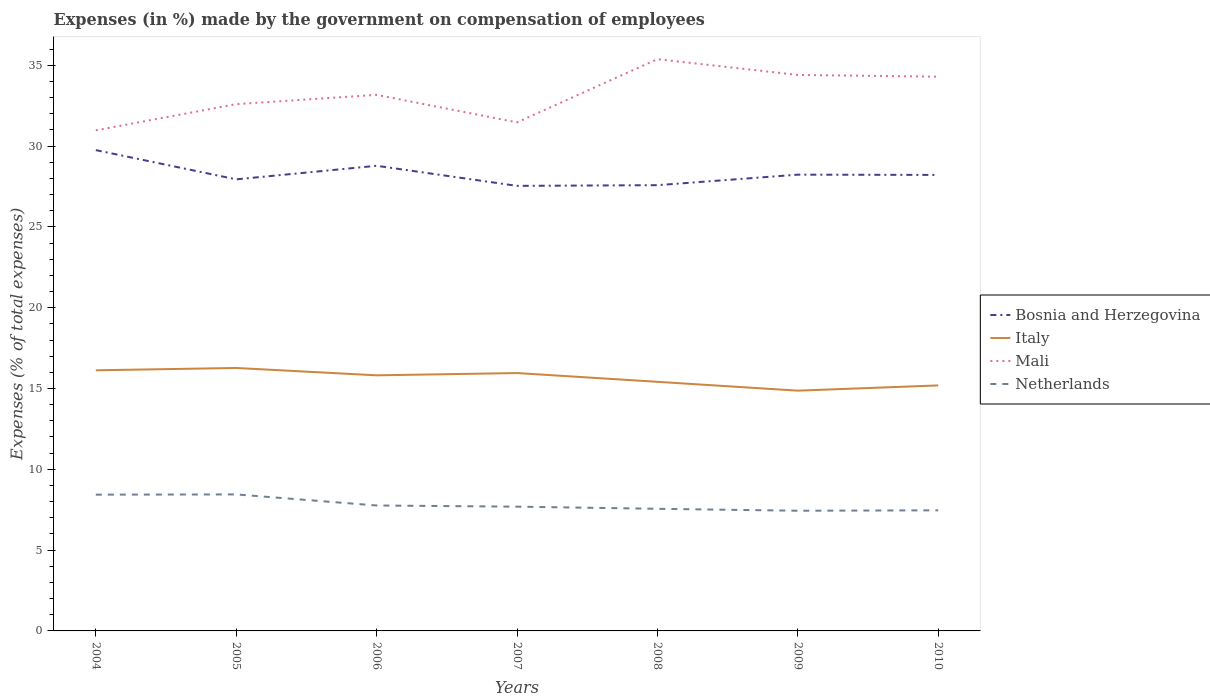Is the number of lines equal to the number of legend labels?
Ensure brevity in your answer.  Yes. Across all years, what is the maximum percentage of expenses made by the government on compensation of employees in Netherlands?
Your response must be concise. 7.44. What is the total percentage of expenses made by the government on compensation of employees in Italy in the graph?
Your response must be concise. 0.31. What is the difference between the highest and the second highest percentage of expenses made by the government on compensation of employees in Bosnia and Herzegovina?
Provide a succinct answer. 2.21. What is the difference between the highest and the lowest percentage of expenses made by the government on compensation of employees in Netherlands?
Provide a short and direct response. 2. How many lines are there?
Provide a succinct answer. 4. How many years are there in the graph?
Offer a terse response. 7. What is the difference between two consecutive major ticks on the Y-axis?
Make the answer very short. 5. Are the values on the major ticks of Y-axis written in scientific E-notation?
Give a very brief answer. No. What is the title of the graph?
Make the answer very short. Expenses (in %) made by the government on compensation of employees. What is the label or title of the Y-axis?
Keep it short and to the point. Expenses (% of total expenses). What is the Expenses (% of total expenses) in Bosnia and Herzegovina in 2004?
Provide a succinct answer. 29.75. What is the Expenses (% of total expenses) of Italy in 2004?
Give a very brief answer. 16.13. What is the Expenses (% of total expenses) of Mali in 2004?
Offer a terse response. 30.98. What is the Expenses (% of total expenses) in Netherlands in 2004?
Ensure brevity in your answer.  8.43. What is the Expenses (% of total expenses) of Bosnia and Herzegovina in 2005?
Ensure brevity in your answer.  27.94. What is the Expenses (% of total expenses) in Italy in 2005?
Your response must be concise. 16.27. What is the Expenses (% of total expenses) in Mali in 2005?
Make the answer very short. 32.6. What is the Expenses (% of total expenses) in Netherlands in 2005?
Make the answer very short. 8.45. What is the Expenses (% of total expenses) in Bosnia and Herzegovina in 2006?
Keep it short and to the point. 28.78. What is the Expenses (% of total expenses) in Italy in 2006?
Give a very brief answer. 15.82. What is the Expenses (% of total expenses) of Mali in 2006?
Your response must be concise. 33.17. What is the Expenses (% of total expenses) in Netherlands in 2006?
Make the answer very short. 7.76. What is the Expenses (% of total expenses) of Bosnia and Herzegovina in 2007?
Your answer should be compact. 27.54. What is the Expenses (% of total expenses) of Italy in 2007?
Your answer should be very brief. 15.96. What is the Expenses (% of total expenses) of Mali in 2007?
Provide a short and direct response. 31.47. What is the Expenses (% of total expenses) of Netherlands in 2007?
Provide a short and direct response. 7.69. What is the Expenses (% of total expenses) of Bosnia and Herzegovina in 2008?
Keep it short and to the point. 27.58. What is the Expenses (% of total expenses) of Italy in 2008?
Make the answer very short. 15.42. What is the Expenses (% of total expenses) of Mali in 2008?
Make the answer very short. 35.38. What is the Expenses (% of total expenses) of Netherlands in 2008?
Your answer should be compact. 7.56. What is the Expenses (% of total expenses) in Bosnia and Herzegovina in 2009?
Your answer should be compact. 28.23. What is the Expenses (% of total expenses) in Italy in 2009?
Make the answer very short. 14.87. What is the Expenses (% of total expenses) in Mali in 2009?
Your answer should be very brief. 34.4. What is the Expenses (% of total expenses) in Netherlands in 2009?
Offer a terse response. 7.44. What is the Expenses (% of total expenses) in Bosnia and Herzegovina in 2010?
Offer a very short reply. 28.22. What is the Expenses (% of total expenses) of Italy in 2010?
Offer a terse response. 15.19. What is the Expenses (% of total expenses) of Mali in 2010?
Give a very brief answer. 34.3. What is the Expenses (% of total expenses) in Netherlands in 2010?
Your answer should be compact. 7.46. Across all years, what is the maximum Expenses (% of total expenses) in Bosnia and Herzegovina?
Provide a short and direct response. 29.75. Across all years, what is the maximum Expenses (% of total expenses) of Italy?
Make the answer very short. 16.27. Across all years, what is the maximum Expenses (% of total expenses) in Mali?
Offer a very short reply. 35.38. Across all years, what is the maximum Expenses (% of total expenses) of Netherlands?
Provide a succinct answer. 8.45. Across all years, what is the minimum Expenses (% of total expenses) of Bosnia and Herzegovina?
Keep it short and to the point. 27.54. Across all years, what is the minimum Expenses (% of total expenses) of Italy?
Make the answer very short. 14.87. Across all years, what is the minimum Expenses (% of total expenses) in Mali?
Ensure brevity in your answer.  30.98. Across all years, what is the minimum Expenses (% of total expenses) of Netherlands?
Your answer should be very brief. 7.44. What is the total Expenses (% of total expenses) of Bosnia and Herzegovina in the graph?
Provide a succinct answer. 198.05. What is the total Expenses (% of total expenses) of Italy in the graph?
Offer a very short reply. 109.65. What is the total Expenses (% of total expenses) in Mali in the graph?
Give a very brief answer. 232.3. What is the total Expenses (% of total expenses) of Netherlands in the graph?
Your answer should be compact. 54.79. What is the difference between the Expenses (% of total expenses) of Bosnia and Herzegovina in 2004 and that in 2005?
Provide a succinct answer. 1.81. What is the difference between the Expenses (% of total expenses) in Italy in 2004 and that in 2005?
Keep it short and to the point. -0.14. What is the difference between the Expenses (% of total expenses) of Mali in 2004 and that in 2005?
Offer a very short reply. -1.62. What is the difference between the Expenses (% of total expenses) of Netherlands in 2004 and that in 2005?
Your response must be concise. -0.01. What is the difference between the Expenses (% of total expenses) of Bosnia and Herzegovina in 2004 and that in 2006?
Give a very brief answer. 0.97. What is the difference between the Expenses (% of total expenses) in Italy in 2004 and that in 2006?
Give a very brief answer. 0.31. What is the difference between the Expenses (% of total expenses) of Mali in 2004 and that in 2006?
Offer a very short reply. -2.2. What is the difference between the Expenses (% of total expenses) of Netherlands in 2004 and that in 2006?
Make the answer very short. 0.67. What is the difference between the Expenses (% of total expenses) of Bosnia and Herzegovina in 2004 and that in 2007?
Give a very brief answer. 2.21. What is the difference between the Expenses (% of total expenses) of Italy in 2004 and that in 2007?
Keep it short and to the point. 0.17. What is the difference between the Expenses (% of total expenses) in Mali in 2004 and that in 2007?
Keep it short and to the point. -0.49. What is the difference between the Expenses (% of total expenses) of Netherlands in 2004 and that in 2007?
Offer a terse response. 0.74. What is the difference between the Expenses (% of total expenses) of Bosnia and Herzegovina in 2004 and that in 2008?
Your response must be concise. 2.17. What is the difference between the Expenses (% of total expenses) in Italy in 2004 and that in 2008?
Ensure brevity in your answer.  0.71. What is the difference between the Expenses (% of total expenses) in Mali in 2004 and that in 2008?
Your answer should be compact. -4.4. What is the difference between the Expenses (% of total expenses) in Netherlands in 2004 and that in 2008?
Provide a short and direct response. 0.88. What is the difference between the Expenses (% of total expenses) of Bosnia and Herzegovina in 2004 and that in 2009?
Offer a very short reply. 1.52. What is the difference between the Expenses (% of total expenses) of Italy in 2004 and that in 2009?
Ensure brevity in your answer.  1.26. What is the difference between the Expenses (% of total expenses) of Mali in 2004 and that in 2009?
Your answer should be very brief. -3.43. What is the difference between the Expenses (% of total expenses) in Bosnia and Herzegovina in 2004 and that in 2010?
Provide a succinct answer. 1.53. What is the difference between the Expenses (% of total expenses) of Italy in 2004 and that in 2010?
Your answer should be compact. 0.94. What is the difference between the Expenses (% of total expenses) of Mali in 2004 and that in 2010?
Your answer should be compact. -3.32. What is the difference between the Expenses (% of total expenses) of Netherlands in 2004 and that in 2010?
Offer a terse response. 0.97. What is the difference between the Expenses (% of total expenses) of Bosnia and Herzegovina in 2005 and that in 2006?
Your answer should be compact. -0.84. What is the difference between the Expenses (% of total expenses) of Italy in 2005 and that in 2006?
Offer a terse response. 0.45. What is the difference between the Expenses (% of total expenses) of Mali in 2005 and that in 2006?
Your answer should be very brief. -0.58. What is the difference between the Expenses (% of total expenses) in Netherlands in 2005 and that in 2006?
Make the answer very short. 0.69. What is the difference between the Expenses (% of total expenses) of Bosnia and Herzegovina in 2005 and that in 2007?
Provide a succinct answer. 0.4. What is the difference between the Expenses (% of total expenses) in Italy in 2005 and that in 2007?
Your answer should be compact. 0.31. What is the difference between the Expenses (% of total expenses) of Mali in 2005 and that in 2007?
Provide a short and direct response. 1.13. What is the difference between the Expenses (% of total expenses) in Netherlands in 2005 and that in 2007?
Offer a terse response. 0.76. What is the difference between the Expenses (% of total expenses) of Bosnia and Herzegovina in 2005 and that in 2008?
Provide a short and direct response. 0.36. What is the difference between the Expenses (% of total expenses) of Italy in 2005 and that in 2008?
Provide a succinct answer. 0.86. What is the difference between the Expenses (% of total expenses) in Mali in 2005 and that in 2008?
Provide a succinct answer. -2.78. What is the difference between the Expenses (% of total expenses) of Netherlands in 2005 and that in 2008?
Your answer should be compact. 0.89. What is the difference between the Expenses (% of total expenses) in Bosnia and Herzegovina in 2005 and that in 2009?
Keep it short and to the point. -0.29. What is the difference between the Expenses (% of total expenses) in Italy in 2005 and that in 2009?
Provide a short and direct response. 1.4. What is the difference between the Expenses (% of total expenses) of Mali in 2005 and that in 2009?
Make the answer very short. -1.81. What is the difference between the Expenses (% of total expenses) of Netherlands in 2005 and that in 2009?
Your answer should be very brief. 1.01. What is the difference between the Expenses (% of total expenses) in Bosnia and Herzegovina in 2005 and that in 2010?
Make the answer very short. -0.27. What is the difference between the Expenses (% of total expenses) in Italy in 2005 and that in 2010?
Make the answer very short. 1.08. What is the difference between the Expenses (% of total expenses) of Mali in 2005 and that in 2010?
Offer a terse response. -1.7. What is the difference between the Expenses (% of total expenses) in Bosnia and Herzegovina in 2006 and that in 2007?
Offer a very short reply. 1.24. What is the difference between the Expenses (% of total expenses) in Italy in 2006 and that in 2007?
Your answer should be very brief. -0.14. What is the difference between the Expenses (% of total expenses) of Mali in 2006 and that in 2007?
Make the answer very short. 1.7. What is the difference between the Expenses (% of total expenses) of Netherlands in 2006 and that in 2007?
Give a very brief answer. 0.07. What is the difference between the Expenses (% of total expenses) in Bosnia and Herzegovina in 2006 and that in 2008?
Offer a terse response. 1.2. What is the difference between the Expenses (% of total expenses) of Italy in 2006 and that in 2008?
Provide a short and direct response. 0.4. What is the difference between the Expenses (% of total expenses) in Mali in 2006 and that in 2008?
Ensure brevity in your answer.  -2.21. What is the difference between the Expenses (% of total expenses) of Netherlands in 2006 and that in 2008?
Ensure brevity in your answer.  0.2. What is the difference between the Expenses (% of total expenses) of Bosnia and Herzegovina in 2006 and that in 2009?
Offer a terse response. 0.55. What is the difference between the Expenses (% of total expenses) in Italy in 2006 and that in 2009?
Provide a succinct answer. 0.95. What is the difference between the Expenses (% of total expenses) of Mali in 2006 and that in 2009?
Make the answer very short. -1.23. What is the difference between the Expenses (% of total expenses) in Netherlands in 2006 and that in 2009?
Your answer should be compact. 0.32. What is the difference between the Expenses (% of total expenses) of Bosnia and Herzegovina in 2006 and that in 2010?
Your answer should be very brief. 0.57. What is the difference between the Expenses (% of total expenses) in Italy in 2006 and that in 2010?
Keep it short and to the point. 0.62. What is the difference between the Expenses (% of total expenses) of Mali in 2006 and that in 2010?
Provide a succinct answer. -1.12. What is the difference between the Expenses (% of total expenses) in Netherlands in 2006 and that in 2010?
Provide a succinct answer. 0.3. What is the difference between the Expenses (% of total expenses) of Bosnia and Herzegovina in 2007 and that in 2008?
Your answer should be compact. -0.04. What is the difference between the Expenses (% of total expenses) of Italy in 2007 and that in 2008?
Ensure brevity in your answer.  0.54. What is the difference between the Expenses (% of total expenses) of Mali in 2007 and that in 2008?
Provide a short and direct response. -3.91. What is the difference between the Expenses (% of total expenses) of Netherlands in 2007 and that in 2008?
Ensure brevity in your answer.  0.13. What is the difference between the Expenses (% of total expenses) of Bosnia and Herzegovina in 2007 and that in 2009?
Your answer should be compact. -0.69. What is the difference between the Expenses (% of total expenses) in Italy in 2007 and that in 2009?
Make the answer very short. 1.09. What is the difference between the Expenses (% of total expenses) of Mali in 2007 and that in 2009?
Your answer should be compact. -2.94. What is the difference between the Expenses (% of total expenses) of Netherlands in 2007 and that in 2009?
Keep it short and to the point. 0.25. What is the difference between the Expenses (% of total expenses) in Bosnia and Herzegovina in 2007 and that in 2010?
Offer a terse response. -0.68. What is the difference between the Expenses (% of total expenses) in Italy in 2007 and that in 2010?
Offer a very short reply. 0.77. What is the difference between the Expenses (% of total expenses) in Mali in 2007 and that in 2010?
Keep it short and to the point. -2.83. What is the difference between the Expenses (% of total expenses) in Netherlands in 2007 and that in 2010?
Provide a short and direct response. 0.23. What is the difference between the Expenses (% of total expenses) of Bosnia and Herzegovina in 2008 and that in 2009?
Give a very brief answer. -0.65. What is the difference between the Expenses (% of total expenses) in Italy in 2008 and that in 2009?
Offer a terse response. 0.55. What is the difference between the Expenses (% of total expenses) in Mali in 2008 and that in 2009?
Offer a terse response. 0.98. What is the difference between the Expenses (% of total expenses) in Netherlands in 2008 and that in 2009?
Provide a short and direct response. 0.12. What is the difference between the Expenses (% of total expenses) of Bosnia and Herzegovina in 2008 and that in 2010?
Make the answer very short. -0.63. What is the difference between the Expenses (% of total expenses) in Italy in 2008 and that in 2010?
Your answer should be compact. 0.22. What is the difference between the Expenses (% of total expenses) in Mali in 2008 and that in 2010?
Offer a terse response. 1.08. What is the difference between the Expenses (% of total expenses) in Netherlands in 2008 and that in 2010?
Ensure brevity in your answer.  0.1. What is the difference between the Expenses (% of total expenses) in Bosnia and Herzegovina in 2009 and that in 2010?
Make the answer very short. 0.02. What is the difference between the Expenses (% of total expenses) in Italy in 2009 and that in 2010?
Offer a terse response. -0.32. What is the difference between the Expenses (% of total expenses) of Mali in 2009 and that in 2010?
Offer a terse response. 0.11. What is the difference between the Expenses (% of total expenses) of Netherlands in 2009 and that in 2010?
Give a very brief answer. -0.02. What is the difference between the Expenses (% of total expenses) of Bosnia and Herzegovina in 2004 and the Expenses (% of total expenses) of Italy in 2005?
Ensure brevity in your answer.  13.48. What is the difference between the Expenses (% of total expenses) in Bosnia and Herzegovina in 2004 and the Expenses (% of total expenses) in Mali in 2005?
Ensure brevity in your answer.  -2.84. What is the difference between the Expenses (% of total expenses) of Bosnia and Herzegovina in 2004 and the Expenses (% of total expenses) of Netherlands in 2005?
Give a very brief answer. 21.31. What is the difference between the Expenses (% of total expenses) in Italy in 2004 and the Expenses (% of total expenses) in Mali in 2005?
Offer a terse response. -16.47. What is the difference between the Expenses (% of total expenses) in Italy in 2004 and the Expenses (% of total expenses) in Netherlands in 2005?
Ensure brevity in your answer.  7.68. What is the difference between the Expenses (% of total expenses) of Mali in 2004 and the Expenses (% of total expenses) of Netherlands in 2005?
Ensure brevity in your answer.  22.53. What is the difference between the Expenses (% of total expenses) in Bosnia and Herzegovina in 2004 and the Expenses (% of total expenses) in Italy in 2006?
Provide a succinct answer. 13.94. What is the difference between the Expenses (% of total expenses) of Bosnia and Herzegovina in 2004 and the Expenses (% of total expenses) of Mali in 2006?
Your response must be concise. -3.42. What is the difference between the Expenses (% of total expenses) of Bosnia and Herzegovina in 2004 and the Expenses (% of total expenses) of Netherlands in 2006?
Provide a short and direct response. 21.99. What is the difference between the Expenses (% of total expenses) of Italy in 2004 and the Expenses (% of total expenses) of Mali in 2006?
Provide a succinct answer. -17.05. What is the difference between the Expenses (% of total expenses) of Italy in 2004 and the Expenses (% of total expenses) of Netherlands in 2006?
Give a very brief answer. 8.37. What is the difference between the Expenses (% of total expenses) in Mali in 2004 and the Expenses (% of total expenses) in Netherlands in 2006?
Your answer should be very brief. 23.22. What is the difference between the Expenses (% of total expenses) in Bosnia and Herzegovina in 2004 and the Expenses (% of total expenses) in Italy in 2007?
Ensure brevity in your answer.  13.79. What is the difference between the Expenses (% of total expenses) of Bosnia and Herzegovina in 2004 and the Expenses (% of total expenses) of Mali in 2007?
Ensure brevity in your answer.  -1.72. What is the difference between the Expenses (% of total expenses) of Bosnia and Herzegovina in 2004 and the Expenses (% of total expenses) of Netherlands in 2007?
Ensure brevity in your answer.  22.06. What is the difference between the Expenses (% of total expenses) in Italy in 2004 and the Expenses (% of total expenses) in Mali in 2007?
Your answer should be very brief. -15.34. What is the difference between the Expenses (% of total expenses) of Italy in 2004 and the Expenses (% of total expenses) of Netherlands in 2007?
Make the answer very short. 8.44. What is the difference between the Expenses (% of total expenses) of Mali in 2004 and the Expenses (% of total expenses) of Netherlands in 2007?
Ensure brevity in your answer.  23.29. What is the difference between the Expenses (% of total expenses) in Bosnia and Herzegovina in 2004 and the Expenses (% of total expenses) in Italy in 2008?
Offer a terse response. 14.34. What is the difference between the Expenses (% of total expenses) in Bosnia and Herzegovina in 2004 and the Expenses (% of total expenses) in Mali in 2008?
Provide a succinct answer. -5.63. What is the difference between the Expenses (% of total expenses) in Bosnia and Herzegovina in 2004 and the Expenses (% of total expenses) in Netherlands in 2008?
Offer a terse response. 22.19. What is the difference between the Expenses (% of total expenses) of Italy in 2004 and the Expenses (% of total expenses) of Mali in 2008?
Your answer should be very brief. -19.25. What is the difference between the Expenses (% of total expenses) of Italy in 2004 and the Expenses (% of total expenses) of Netherlands in 2008?
Offer a terse response. 8.57. What is the difference between the Expenses (% of total expenses) in Mali in 2004 and the Expenses (% of total expenses) in Netherlands in 2008?
Provide a succinct answer. 23.42. What is the difference between the Expenses (% of total expenses) of Bosnia and Herzegovina in 2004 and the Expenses (% of total expenses) of Italy in 2009?
Ensure brevity in your answer.  14.88. What is the difference between the Expenses (% of total expenses) in Bosnia and Herzegovina in 2004 and the Expenses (% of total expenses) in Mali in 2009?
Offer a very short reply. -4.65. What is the difference between the Expenses (% of total expenses) of Bosnia and Herzegovina in 2004 and the Expenses (% of total expenses) of Netherlands in 2009?
Offer a very short reply. 22.32. What is the difference between the Expenses (% of total expenses) of Italy in 2004 and the Expenses (% of total expenses) of Mali in 2009?
Your answer should be very brief. -18.28. What is the difference between the Expenses (% of total expenses) of Italy in 2004 and the Expenses (% of total expenses) of Netherlands in 2009?
Provide a succinct answer. 8.69. What is the difference between the Expenses (% of total expenses) of Mali in 2004 and the Expenses (% of total expenses) of Netherlands in 2009?
Make the answer very short. 23.54. What is the difference between the Expenses (% of total expenses) of Bosnia and Herzegovina in 2004 and the Expenses (% of total expenses) of Italy in 2010?
Your answer should be compact. 14.56. What is the difference between the Expenses (% of total expenses) in Bosnia and Herzegovina in 2004 and the Expenses (% of total expenses) in Mali in 2010?
Offer a terse response. -4.54. What is the difference between the Expenses (% of total expenses) in Bosnia and Herzegovina in 2004 and the Expenses (% of total expenses) in Netherlands in 2010?
Your answer should be compact. 22.29. What is the difference between the Expenses (% of total expenses) of Italy in 2004 and the Expenses (% of total expenses) of Mali in 2010?
Give a very brief answer. -18.17. What is the difference between the Expenses (% of total expenses) in Italy in 2004 and the Expenses (% of total expenses) in Netherlands in 2010?
Your response must be concise. 8.67. What is the difference between the Expenses (% of total expenses) of Mali in 2004 and the Expenses (% of total expenses) of Netherlands in 2010?
Provide a succinct answer. 23.52. What is the difference between the Expenses (% of total expenses) in Bosnia and Herzegovina in 2005 and the Expenses (% of total expenses) in Italy in 2006?
Your response must be concise. 12.13. What is the difference between the Expenses (% of total expenses) in Bosnia and Herzegovina in 2005 and the Expenses (% of total expenses) in Mali in 2006?
Keep it short and to the point. -5.23. What is the difference between the Expenses (% of total expenses) of Bosnia and Herzegovina in 2005 and the Expenses (% of total expenses) of Netherlands in 2006?
Keep it short and to the point. 20.18. What is the difference between the Expenses (% of total expenses) in Italy in 2005 and the Expenses (% of total expenses) in Mali in 2006?
Keep it short and to the point. -16.9. What is the difference between the Expenses (% of total expenses) of Italy in 2005 and the Expenses (% of total expenses) of Netherlands in 2006?
Provide a short and direct response. 8.51. What is the difference between the Expenses (% of total expenses) in Mali in 2005 and the Expenses (% of total expenses) in Netherlands in 2006?
Keep it short and to the point. 24.84. What is the difference between the Expenses (% of total expenses) of Bosnia and Herzegovina in 2005 and the Expenses (% of total expenses) of Italy in 2007?
Ensure brevity in your answer.  11.99. What is the difference between the Expenses (% of total expenses) of Bosnia and Herzegovina in 2005 and the Expenses (% of total expenses) of Mali in 2007?
Provide a short and direct response. -3.52. What is the difference between the Expenses (% of total expenses) in Bosnia and Herzegovina in 2005 and the Expenses (% of total expenses) in Netherlands in 2007?
Offer a very short reply. 20.25. What is the difference between the Expenses (% of total expenses) of Italy in 2005 and the Expenses (% of total expenses) of Mali in 2007?
Offer a terse response. -15.2. What is the difference between the Expenses (% of total expenses) in Italy in 2005 and the Expenses (% of total expenses) in Netherlands in 2007?
Make the answer very short. 8.58. What is the difference between the Expenses (% of total expenses) in Mali in 2005 and the Expenses (% of total expenses) in Netherlands in 2007?
Make the answer very short. 24.91. What is the difference between the Expenses (% of total expenses) of Bosnia and Herzegovina in 2005 and the Expenses (% of total expenses) of Italy in 2008?
Provide a short and direct response. 12.53. What is the difference between the Expenses (% of total expenses) of Bosnia and Herzegovina in 2005 and the Expenses (% of total expenses) of Mali in 2008?
Give a very brief answer. -7.44. What is the difference between the Expenses (% of total expenses) of Bosnia and Herzegovina in 2005 and the Expenses (% of total expenses) of Netherlands in 2008?
Your response must be concise. 20.39. What is the difference between the Expenses (% of total expenses) in Italy in 2005 and the Expenses (% of total expenses) in Mali in 2008?
Keep it short and to the point. -19.11. What is the difference between the Expenses (% of total expenses) in Italy in 2005 and the Expenses (% of total expenses) in Netherlands in 2008?
Your answer should be very brief. 8.71. What is the difference between the Expenses (% of total expenses) of Mali in 2005 and the Expenses (% of total expenses) of Netherlands in 2008?
Your answer should be compact. 25.04. What is the difference between the Expenses (% of total expenses) of Bosnia and Herzegovina in 2005 and the Expenses (% of total expenses) of Italy in 2009?
Offer a terse response. 13.08. What is the difference between the Expenses (% of total expenses) of Bosnia and Herzegovina in 2005 and the Expenses (% of total expenses) of Mali in 2009?
Keep it short and to the point. -6.46. What is the difference between the Expenses (% of total expenses) of Bosnia and Herzegovina in 2005 and the Expenses (% of total expenses) of Netherlands in 2009?
Make the answer very short. 20.51. What is the difference between the Expenses (% of total expenses) in Italy in 2005 and the Expenses (% of total expenses) in Mali in 2009?
Provide a short and direct response. -18.13. What is the difference between the Expenses (% of total expenses) of Italy in 2005 and the Expenses (% of total expenses) of Netherlands in 2009?
Your answer should be very brief. 8.83. What is the difference between the Expenses (% of total expenses) in Mali in 2005 and the Expenses (% of total expenses) in Netherlands in 2009?
Keep it short and to the point. 25.16. What is the difference between the Expenses (% of total expenses) in Bosnia and Herzegovina in 2005 and the Expenses (% of total expenses) in Italy in 2010?
Keep it short and to the point. 12.75. What is the difference between the Expenses (% of total expenses) of Bosnia and Herzegovina in 2005 and the Expenses (% of total expenses) of Mali in 2010?
Make the answer very short. -6.35. What is the difference between the Expenses (% of total expenses) in Bosnia and Herzegovina in 2005 and the Expenses (% of total expenses) in Netherlands in 2010?
Keep it short and to the point. 20.48. What is the difference between the Expenses (% of total expenses) of Italy in 2005 and the Expenses (% of total expenses) of Mali in 2010?
Your answer should be compact. -18.03. What is the difference between the Expenses (% of total expenses) in Italy in 2005 and the Expenses (% of total expenses) in Netherlands in 2010?
Your answer should be very brief. 8.81. What is the difference between the Expenses (% of total expenses) in Mali in 2005 and the Expenses (% of total expenses) in Netherlands in 2010?
Your response must be concise. 25.13. What is the difference between the Expenses (% of total expenses) of Bosnia and Herzegovina in 2006 and the Expenses (% of total expenses) of Italy in 2007?
Ensure brevity in your answer.  12.83. What is the difference between the Expenses (% of total expenses) in Bosnia and Herzegovina in 2006 and the Expenses (% of total expenses) in Mali in 2007?
Provide a short and direct response. -2.69. What is the difference between the Expenses (% of total expenses) in Bosnia and Herzegovina in 2006 and the Expenses (% of total expenses) in Netherlands in 2007?
Your answer should be compact. 21.09. What is the difference between the Expenses (% of total expenses) in Italy in 2006 and the Expenses (% of total expenses) in Mali in 2007?
Provide a short and direct response. -15.65. What is the difference between the Expenses (% of total expenses) of Italy in 2006 and the Expenses (% of total expenses) of Netherlands in 2007?
Your answer should be very brief. 8.13. What is the difference between the Expenses (% of total expenses) of Mali in 2006 and the Expenses (% of total expenses) of Netherlands in 2007?
Provide a succinct answer. 25.48. What is the difference between the Expenses (% of total expenses) of Bosnia and Herzegovina in 2006 and the Expenses (% of total expenses) of Italy in 2008?
Offer a terse response. 13.37. What is the difference between the Expenses (% of total expenses) of Bosnia and Herzegovina in 2006 and the Expenses (% of total expenses) of Mali in 2008?
Keep it short and to the point. -6.6. What is the difference between the Expenses (% of total expenses) of Bosnia and Herzegovina in 2006 and the Expenses (% of total expenses) of Netherlands in 2008?
Provide a succinct answer. 21.23. What is the difference between the Expenses (% of total expenses) of Italy in 2006 and the Expenses (% of total expenses) of Mali in 2008?
Ensure brevity in your answer.  -19.56. What is the difference between the Expenses (% of total expenses) in Italy in 2006 and the Expenses (% of total expenses) in Netherlands in 2008?
Give a very brief answer. 8.26. What is the difference between the Expenses (% of total expenses) in Mali in 2006 and the Expenses (% of total expenses) in Netherlands in 2008?
Provide a short and direct response. 25.62. What is the difference between the Expenses (% of total expenses) in Bosnia and Herzegovina in 2006 and the Expenses (% of total expenses) in Italy in 2009?
Offer a very short reply. 13.92. What is the difference between the Expenses (% of total expenses) of Bosnia and Herzegovina in 2006 and the Expenses (% of total expenses) of Mali in 2009?
Keep it short and to the point. -5.62. What is the difference between the Expenses (% of total expenses) in Bosnia and Herzegovina in 2006 and the Expenses (% of total expenses) in Netherlands in 2009?
Offer a very short reply. 21.35. What is the difference between the Expenses (% of total expenses) in Italy in 2006 and the Expenses (% of total expenses) in Mali in 2009?
Offer a very short reply. -18.59. What is the difference between the Expenses (% of total expenses) of Italy in 2006 and the Expenses (% of total expenses) of Netherlands in 2009?
Give a very brief answer. 8.38. What is the difference between the Expenses (% of total expenses) in Mali in 2006 and the Expenses (% of total expenses) in Netherlands in 2009?
Your answer should be very brief. 25.74. What is the difference between the Expenses (% of total expenses) in Bosnia and Herzegovina in 2006 and the Expenses (% of total expenses) in Italy in 2010?
Keep it short and to the point. 13.59. What is the difference between the Expenses (% of total expenses) of Bosnia and Herzegovina in 2006 and the Expenses (% of total expenses) of Mali in 2010?
Give a very brief answer. -5.51. What is the difference between the Expenses (% of total expenses) of Bosnia and Herzegovina in 2006 and the Expenses (% of total expenses) of Netherlands in 2010?
Your answer should be very brief. 21.32. What is the difference between the Expenses (% of total expenses) of Italy in 2006 and the Expenses (% of total expenses) of Mali in 2010?
Ensure brevity in your answer.  -18.48. What is the difference between the Expenses (% of total expenses) in Italy in 2006 and the Expenses (% of total expenses) in Netherlands in 2010?
Ensure brevity in your answer.  8.35. What is the difference between the Expenses (% of total expenses) in Mali in 2006 and the Expenses (% of total expenses) in Netherlands in 2010?
Offer a very short reply. 25.71. What is the difference between the Expenses (% of total expenses) in Bosnia and Herzegovina in 2007 and the Expenses (% of total expenses) in Italy in 2008?
Give a very brief answer. 12.12. What is the difference between the Expenses (% of total expenses) of Bosnia and Herzegovina in 2007 and the Expenses (% of total expenses) of Mali in 2008?
Your answer should be compact. -7.84. What is the difference between the Expenses (% of total expenses) in Bosnia and Herzegovina in 2007 and the Expenses (% of total expenses) in Netherlands in 2008?
Your response must be concise. 19.98. What is the difference between the Expenses (% of total expenses) in Italy in 2007 and the Expenses (% of total expenses) in Mali in 2008?
Offer a terse response. -19.42. What is the difference between the Expenses (% of total expenses) of Mali in 2007 and the Expenses (% of total expenses) of Netherlands in 2008?
Your response must be concise. 23.91. What is the difference between the Expenses (% of total expenses) in Bosnia and Herzegovina in 2007 and the Expenses (% of total expenses) in Italy in 2009?
Your answer should be compact. 12.67. What is the difference between the Expenses (% of total expenses) of Bosnia and Herzegovina in 2007 and the Expenses (% of total expenses) of Mali in 2009?
Provide a short and direct response. -6.86. What is the difference between the Expenses (% of total expenses) of Bosnia and Herzegovina in 2007 and the Expenses (% of total expenses) of Netherlands in 2009?
Keep it short and to the point. 20.1. What is the difference between the Expenses (% of total expenses) of Italy in 2007 and the Expenses (% of total expenses) of Mali in 2009?
Ensure brevity in your answer.  -18.45. What is the difference between the Expenses (% of total expenses) in Italy in 2007 and the Expenses (% of total expenses) in Netherlands in 2009?
Provide a short and direct response. 8.52. What is the difference between the Expenses (% of total expenses) in Mali in 2007 and the Expenses (% of total expenses) in Netherlands in 2009?
Ensure brevity in your answer.  24.03. What is the difference between the Expenses (% of total expenses) of Bosnia and Herzegovina in 2007 and the Expenses (% of total expenses) of Italy in 2010?
Your response must be concise. 12.35. What is the difference between the Expenses (% of total expenses) of Bosnia and Herzegovina in 2007 and the Expenses (% of total expenses) of Mali in 2010?
Offer a terse response. -6.76. What is the difference between the Expenses (% of total expenses) in Bosnia and Herzegovina in 2007 and the Expenses (% of total expenses) in Netherlands in 2010?
Ensure brevity in your answer.  20.08. What is the difference between the Expenses (% of total expenses) in Italy in 2007 and the Expenses (% of total expenses) in Mali in 2010?
Offer a terse response. -18.34. What is the difference between the Expenses (% of total expenses) in Italy in 2007 and the Expenses (% of total expenses) in Netherlands in 2010?
Your response must be concise. 8.5. What is the difference between the Expenses (% of total expenses) in Mali in 2007 and the Expenses (% of total expenses) in Netherlands in 2010?
Provide a short and direct response. 24.01. What is the difference between the Expenses (% of total expenses) in Bosnia and Herzegovina in 2008 and the Expenses (% of total expenses) in Italy in 2009?
Offer a terse response. 12.72. What is the difference between the Expenses (% of total expenses) in Bosnia and Herzegovina in 2008 and the Expenses (% of total expenses) in Mali in 2009?
Offer a very short reply. -6.82. What is the difference between the Expenses (% of total expenses) in Bosnia and Herzegovina in 2008 and the Expenses (% of total expenses) in Netherlands in 2009?
Your answer should be very brief. 20.15. What is the difference between the Expenses (% of total expenses) in Italy in 2008 and the Expenses (% of total expenses) in Mali in 2009?
Your answer should be compact. -18.99. What is the difference between the Expenses (% of total expenses) of Italy in 2008 and the Expenses (% of total expenses) of Netherlands in 2009?
Your answer should be compact. 7.98. What is the difference between the Expenses (% of total expenses) of Mali in 2008 and the Expenses (% of total expenses) of Netherlands in 2009?
Keep it short and to the point. 27.94. What is the difference between the Expenses (% of total expenses) in Bosnia and Herzegovina in 2008 and the Expenses (% of total expenses) in Italy in 2010?
Keep it short and to the point. 12.39. What is the difference between the Expenses (% of total expenses) of Bosnia and Herzegovina in 2008 and the Expenses (% of total expenses) of Mali in 2010?
Offer a very short reply. -6.71. What is the difference between the Expenses (% of total expenses) of Bosnia and Herzegovina in 2008 and the Expenses (% of total expenses) of Netherlands in 2010?
Keep it short and to the point. 20.12. What is the difference between the Expenses (% of total expenses) in Italy in 2008 and the Expenses (% of total expenses) in Mali in 2010?
Your answer should be compact. -18.88. What is the difference between the Expenses (% of total expenses) of Italy in 2008 and the Expenses (% of total expenses) of Netherlands in 2010?
Your answer should be very brief. 7.95. What is the difference between the Expenses (% of total expenses) in Mali in 2008 and the Expenses (% of total expenses) in Netherlands in 2010?
Make the answer very short. 27.92. What is the difference between the Expenses (% of total expenses) in Bosnia and Herzegovina in 2009 and the Expenses (% of total expenses) in Italy in 2010?
Your answer should be very brief. 13.04. What is the difference between the Expenses (% of total expenses) in Bosnia and Herzegovina in 2009 and the Expenses (% of total expenses) in Mali in 2010?
Ensure brevity in your answer.  -6.06. What is the difference between the Expenses (% of total expenses) of Bosnia and Herzegovina in 2009 and the Expenses (% of total expenses) of Netherlands in 2010?
Provide a succinct answer. 20.77. What is the difference between the Expenses (% of total expenses) of Italy in 2009 and the Expenses (% of total expenses) of Mali in 2010?
Make the answer very short. -19.43. What is the difference between the Expenses (% of total expenses) of Italy in 2009 and the Expenses (% of total expenses) of Netherlands in 2010?
Keep it short and to the point. 7.41. What is the difference between the Expenses (% of total expenses) in Mali in 2009 and the Expenses (% of total expenses) in Netherlands in 2010?
Give a very brief answer. 26.94. What is the average Expenses (% of total expenses) of Bosnia and Herzegovina per year?
Keep it short and to the point. 28.29. What is the average Expenses (% of total expenses) of Italy per year?
Offer a terse response. 15.66. What is the average Expenses (% of total expenses) in Mali per year?
Give a very brief answer. 33.19. What is the average Expenses (% of total expenses) in Netherlands per year?
Ensure brevity in your answer.  7.83. In the year 2004, what is the difference between the Expenses (% of total expenses) of Bosnia and Herzegovina and Expenses (% of total expenses) of Italy?
Keep it short and to the point. 13.62. In the year 2004, what is the difference between the Expenses (% of total expenses) of Bosnia and Herzegovina and Expenses (% of total expenses) of Mali?
Provide a succinct answer. -1.23. In the year 2004, what is the difference between the Expenses (% of total expenses) of Bosnia and Herzegovina and Expenses (% of total expenses) of Netherlands?
Ensure brevity in your answer.  21.32. In the year 2004, what is the difference between the Expenses (% of total expenses) of Italy and Expenses (% of total expenses) of Mali?
Provide a short and direct response. -14.85. In the year 2004, what is the difference between the Expenses (% of total expenses) in Italy and Expenses (% of total expenses) in Netherlands?
Offer a terse response. 7.69. In the year 2004, what is the difference between the Expenses (% of total expenses) of Mali and Expenses (% of total expenses) of Netherlands?
Keep it short and to the point. 22.54. In the year 2005, what is the difference between the Expenses (% of total expenses) in Bosnia and Herzegovina and Expenses (% of total expenses) in Italy?
Keep it short and to the point. 11.67. In the year 2005, what is the difference between the Expenses (% of total expenses) in Bosnia and Herzegovina and Expenses (% of total expenses) in Mali?
Give a very brief answer. -4.65. In the year 2005, what is the difference between the Expenses (% of total expenses) in Bosnia and Herzegovina and Expenses (% of total expenses) in Netherlands?
Make the answer very short. 19.5. In the year 2005, what is the difference between the Expenses (% of total expenses) of Italy and Expenses (% of total expenses) of Mali?
Your answer should be compact. -16.33. In the year 2005, what is the difference between the Expenses (% of total expenses) in Italy and Expenses (% of total expenses) in Netherlands?
Your answer should be very brief. 7.82. In the year 2005, what is the difference between the Expenses (% of total expenses) in Mali and Expenses (% of total expenses) in Netherlands?
Your response must be concise. 24.15. In the year 2006, what is the difference between the Expenses (% of total expenses) in Bosnia and Herzegovina and Expenses (% of total expenses) in Italy?
Your answer should be very brief. 12.97. In the year 2006, what is the difference between the Expenses (% of total expenses) of Bosnia and Herzegovina and Expenses (% of total expenses) of Mali?
Keep it short and to the point. -4.39. In the year 2006, what is the difference between the Expenses (% of total expenses) of Bosnia and Herzegovina and Expenses (% of total expenses) of Netherlands?
Offer a terse response. 21.02. In the year 2006, what is the difference between the Expenses (% of total expenses) in Italy and Expenses (% of total expenses) in Mali?
Provide a succinct answer. -17.36. In the year 2006, what is the difference between the Expenses (% of total expenses) in Italy and Expenses (% of total expenses) in Netherlands?
Provide a short and direct response. 8.05. In the year 2006, what is the difference between the Expenses (% of total expenses) of Mali and Expenses (% of total expenses) of Netherlands?
Your response must be concise. 25.41. In the year 2007, what is the difference between the Expenses (% of total expenses) of Bosnia and Herzegovina and Expenses (% of total expenses) of Italy?
Keep it short and to the point. 11.58. In the year 2007, what is the difference between the Expenses (% of total expenses) in Bosnia and Herzegovina and Expenses (% of total expenses) in Mali?
Your answer should be very brief. -3.93. In the year 2007, what is the difference between the Expenses (% of total expenses) of Bosnia and Herzegovina and Expenses (% of total expenses) of Netherlands?
Offer a terse response. 19.85. In the year 2007, what is the difference between the Expenses (% of total expenses) in Italy and Expenses (% of total expenses) in Mali?
Your response must be concise. -15.51. In the year 2007, what is the difference between the Expenses (% of total expenses) of Italy and Expenses (% of total expenses) of Netherlands?
Your answer should be compact. 8.27. In the year 2007, what is the difference between the Expenses (% of total expenses) of Mali and Expenses (% of total expenses) of Netherlands?
Your answer should be compact. 23.78. In the year 2008, what is the difference between the Expenses (% of total expenses) of Bosnia and Herzegovina and Expenses (% of total expenses) of Italy?
Ensure brevity in your answer.  12.17. In the year 2008, what is the difference between the Expenses (% of total expenses) of Bosnia and Herzegovina and Expenses (% of total expenses) of Mali?
Your response must be concise. -7.8. In the year 2008, what is the difference between the Expenses (% of total expenses) in Bosnia and Herzegovina and Expenses (% of total expenses) in Netherlands?
Keep it short and to the point. 20.03. In the year 2008, what is the difference between the Expenses (% of total expenses) in Italy and Expenses (% of total expenses) in Mali?
Give a very brief answer. -19.97. In the year 2008, what is the difference between the Expenses (% of total expenses) of Italy and Expenses (% of total expenses) of Netherlands?
Offer a very short reply. 7.86. In the year 2008, what is the difference between the Expenses (% of total expenses) of Mali and Expenses (% of total expenses) of Netherlands?
Offer a terse response. 27.82. In the year 2009, what is the difference between the Expenses (% of total expenses) of Bosnia and Herzegovina and Expenses (% of total expenses) of Italy?
Your answer should be compact. 13.37. In the year 2009, what is the difference between the Expenses (% of total expenses) in Bosnia and Herzegovina and Expenses (% of total expenses) in Mali?
Offer a terse response. -6.17. In the year 2009, what is the difference between the Expenses (% of total expenses) of Bosnia and Herzegovina and Expenses (% of total expenses) of Netherlands?
Provide a succinct answer. 20.8. In the year 2009, what is the difference between the Expenses (% of total expenses) of Italy and Expenses (% of total expenses) of Mali?
Offer a terse response. -19.54. In the year 2009, what is the difference between the Expenses (% of total expenses) in Italy and Expenses (% of total expenses) in Netherlands?
Make the answer very short. 7.43. In the year 2009, what is the difference between the Expenses (% of total expenses) in Mali and Expenses (% of total expenses) in Netherlands?
Offer a terse response. 26.97. In the year 2010, what is the difference between the Expenses (% of total expenses) in Bosnia and Herzegovina and Expenses (% of total expenses) in Italy?
Keep it short and to the point. 13.03. In the year 2010, what is the difference between the Expenses (% of total expenses) in Bosnia and Herzegovina and Expenses (% of total expenses) in Mali?
Provide a succinct answer. -6.08. In the year 2010, what is the difference between the Expenses (% of total expenses) in Bosnia and Herzegovina and Expenses (% of total expenses) in Netherlands?
Your answer should be compact. 20.76. In the year 2010, what is the difference between the Expenses (% of total expenses) in Italy and Expenses (% of total expenses) in Mali?
Give a very brief answer. -19.11. In the year 2010, what is the difference between the Expenses (% of total expenses) in Italy and Expenses (% of total expenses) in Netherlands?
Make the answer very short. 7.73. In the year 2010, what is the difference between the Expenses (% of total expenses) in Mali and Expenses (% of total expenses) in Netherlands?
Keep it short and to the point. 26.83. What is the ratio of the Expenses (% of total expenses) in Bosnia and Herzegovina in 2004 to that in 2005?
Your answer should be very brief. 1.06. What is the ratio of the Expenses (% of total expenses) of Italy in 2004 to that in 2005?
Keep it short and to the point. 0.99. What is the ratio of the Expenses (% of total expenses) in Mali in 2004 to that in 2005?
Your answer should be very brief. 0.95. What is the ratio of the Expenses (% of total expenses) in Netherlands in 2004 to that in 2005?
Give a very brief answer. 1. What is the ratio of the Expenses (% of total expenses) of Bosnia and Herzegovina in 2004 to that in 2006?
Keep it short and to the point. 1.03. What is the ratio of the Expenses (% of total expenses) in Italy in 2004 to that in 2006?
Ensure brevity in your answer.  1.02. What is the ratio of the Expenses (% of total expenses) of Mali in 2004 to that in 2006?
Your answer should be compact. 0.93. What is the ratio of the Expenses (% of total expenses) of Netherlands in 2004 to that in 2006?
Your answer should be compact. 1.09. What is the ratio of the Expenses (% of total expenses) of Bosnia and Herzegovina in 2004 to that in 2007?
Ensure brevity in your answer.  1.08. What is the ratio of the Expenses (% of total expenses) in Italy in 2004 to that in 2007?
Provide a succinct answer. 1.01. What is the ratio of the Expenses (% of total expenses) of Mali in 2004 to that in 2007?
Provide a succinct answer. 0.98. What is the ratio of the Expenses (% of total expenses) of Netherlands in 2004 to that in 2007?
Your response must be concise. 1.1. What is the ratio of the Expenses (% of total expenses) in Bosnia and Herzegovina in 2004 to that in 2008?
Your answer should be very brief. 1.08. What is the ratio of the Expenses (% of total expenses) of Italy in 2004 to that in 2008?
Your response must be concise. 1.05. What is the ratio of the Expenses (% of total expenses) in Mali in 2004 to that in 2008?
Your response must be concise. 0.88. What is the ratio of the Expenses (% of total expenses) in Netherlands in 2004 to that in 2008?
Make the answer very short. 1.12. What is the ratio of the Expenses (% of total expenses) of Bosnia and Herzegovina in 2004 to that in 2009?
Your response must be concise. 1.05. What is the ratio of the Expenses (% of total expenses) in Italy in 2004 to that in 2009?
Ensure brevity in your answer.  1.08. What is the ratio of the Expenses (% of total expenses) of Mali in 2004 to that in 2009?
Provide a short and direct response. 0.9. What is the ratio of the Expenses (% of total expenses) of Netherlands in 2004 to that in 2009?
Give a very brief answer. 1.13. What is the ratio of the Expenses (% of total expenses) in Bosnia and Herzegovina in 2004 to that in 2010?
Ensure brevity in your answer.  1.05. What is the ratio of the Expenses (% of total expenses) of Italy in 2004 to that in 2010?
Provide a short and direct response. 1.06. What is the ratio of the Expenses (% of total expenses) of Mali in 2004 to that in 2010?
Offer a terse response. 0.9. What is the ratio of the Expenses (% of total expenses) of Netherlands in 2004 to that in 2010?
Provide a short and direct response. 1.13. What is the ratio of the Expenses (% of total expenses) in Bosnia and Herzegovina in 2005 to that in 2006?
Your answer should be compact. 0.97. What is the ratio of the Expenses (% of total expenses) in Italy in 2005 to that in 2006?
Offer a very short reply. 1.03. What is the ratio of the Expenses (% of total expenses) in Mali in 2005 to that in 2006?
Provide a short and direct response. 0.98. What is the ratio of the Expenses (% of total expenses) in Netherlands in 2005 to that in 2006?
Your answer should be very brief. 1.09. What is the ratio of the Expenses (% of total expenses) in Bosnia and Herzegovina in 2005 to that in 2007?
Make the answer very short. 1.01. What is the ratio of the Expenses (% of total expenses) of Italy in 2005 to that in 2007?
Provide a short and direct response. 1.02. What is the ratio of the Expenses (% of total expenses) of Mali in 2005 to that in 2007?
Your response must be concise. 1.04. What is the ratio of the Expenses (% of total expenses) of Netherlands in 2005 to that in 2007?
Provide a short and direct response. 1.1. What is the ratio of the Expenses (% of total expenses) of Bosnia and Herzegovina in 2005 to that in 2008?
Give a very brief answer. 1.01. What is the ratio of the Expenses (% of total expenses) in Italy in 2005 to that in 2008?
Offer a terse response. 1.06. What is the ratio of the Expenses (% of total expenses) in Mali in 2005 to that in 2008?
Give a very brief answer. 0.92. What is the ratio of the Expenses (% of total expenses) of Netherlands in 2005 to that in 2008?
Your answer should be very brief. 1.12. What is the ratio of the Expenses (% of total expenses) of Italy in 2005 to that in 2009?
Give a very brief answer. 1.09. What is the ratio of the Expenses (% of total expenses) in Mali in 2005 to that in 2009?
Keep it short and to the point. 0.95. What is the ratio of the Expenses (% of total expenses) of Netherlands in 2005 to that in 2009?
Ensure brevity in your answer.  1.14. What is the ratio of the Expenses (% of total expenses) in Bosnia and Herzegovina in 2005 to that in 2010?
Ensure brevity in your answer.  0.99. What is the ratio of the Expenses (% of total expenses) in Italy in 2005 to that in 2010?
Give a very brief answer. 1.07. What is the ratio of the Expenses (% of total expenses) of Mali in 2005 to that in 2010?
Offer a very short reply. 0.95. What is the ratio of the Expenses (% of total expenses) of Netherlands in 2005 to that in 2010?
Keep it short and to the point. 1.13. What is the ratio of the Expenses (% of total expenses) in Bosnia and Herzegovina in 2006 to that in 2007?
Your response must be concise. 1.05. What is the ratio of the Expenses (% of total expenses) in Mali in 2006 to that in 2007?
Provide a succinct answer. 1.05. What is the ratio of the Expenses (% of total expenses) of Netherlands in 2006 to that in 2007?
Provide a succinct answer. 1.01. What is the ratio of the Expenses (% of total expenses) of Bosnia and Herzegovina in 2006 to that in 2008?
Give a very brief answer. 1.04. What is the ratio of the Expenses (% of total expenses) in Mali in 2006 to that in 2008?
Provide a short and direct response. 0.94. What is the ratio of the Expenses (% of total expenses) of Netherlands in 2006 to that in 2008?
Provide a short and direct response. 1.03. What is the ratio of the Expenses (% of total expenses) in Bosnia and Herzegovina in 2006 to that in 2009?
Ensure brevity in your answer.  1.02. What is the ratio of the Expenses (% of total expenses) in Italy in 2006 to that in 2009?
Offer a terse response. 1.06. What is the ratio of the Expenses (% of total expenses) in Mali in 2006 to that in 2009?
Your response must be concise. 0.96. What is the ratio of the Expenses (% of total expenses) of Netherlands in 2006 to that in 2009?
Offer a terse response. 1.04. What is the ratio of the Expenses (% of total expenses) in Bosnia and Herzegovina in 2006 to that in 2010?
Your response must be concise. 1.02. What is the ratio of the Expenses (% of total expenses) of Italy in 2006 to that in 2010?
Your answer should be compact. 1.04. What is the ratio of the Expenses (% of total expenses) of Mali in 2006 to that in 2010?
Keep it short and to the point. 0.97. What is the ratio of the Expenses (% of total expenses) in Netherlands in 2006 to that in 2010?
Your answer should be very brief. 1.04. What is the ratio of the Expenses (% of total expenses) in Bosnia and Herzegovina in 2007 to that in 2008?
Give a very brief answer. 1. What is the ratio of the Expenses (% of total expenses) in Italy in 2007 to that in 2008?
Give a very brief answer. 1.04. What is the ratio of the Expenses (% of total expenses) of Mali in 2007 to that in 2008?
Your response must be concise. 0.89. What is the ratio of the Expenses (% of total expenses) in Netherlands in 2007 to that in 2008?
Provide a short and direct response. 1.02. What is the ratio of the Expenses (% of total expenses) of Bosnia and Herzegovina in 2007 to that in 2009?
Ensure brevity in your answer.  0.98. What is the ratio of the Expenses (% of total expenses) in Italy in 2007 to that in 2009?
Your response must be concise. 1.07. What is the ratio of the Expenses (% of total expenses) in Mali in 2007 to that in 2009?
Your answer should be compact. 0.91. What is the ratio of the Expenses (% of total expenses) of Netherlands in 2007 to that in 2009?
Your answer should be compact. 1.03. What is the ratio of the Expenses (% of total expenses) of Italy in 2007 to that in 2010?
Your answer should be very brief. 1.05. What is the ratio of the Expenses (% of total expenses) in Mali in 2007 to that in 2010?
Make the answer very short. 0.92. What is the ratio of the Expenses (% of total expenses) of Netherlands in 2007 to that in 2010?
Offer a terse response. 1.03. What is the ratio of the Expenses (% of total expenses) of Italy in 2008 to that in 2009?
Your answer should be compact. 1.04. What is the ratio of the Expenses (% of total expenses) of Mali in 2008 to that in 2009?
Give a very brief answer. 1.03. What is the ratio of the Expenses (% of total expenses) in Netherlands in 2008 to that in 2009?
Make the answer very short. 1.02. What is the ratio of the Expenses (% of total expenses) in Bosnia and Herzegovina in 2008 to that in 2010?
Your response must be concise. 0.98. What is the ratio of the Expenses (% of total expenses) of Italy in 2008 to that in 2010?
Your answer should be very brief. 1.01. What is the ratio of the Expenses (% of total expenses) of Mali in 2008 to that in 2010?
Ensure brevity in your answer.  1.03. What is the ratio of the Expenses (% of total expenses) in Netherlands in 2008 to that in 2010?
Your response must be concise. 1.01. What is the ratio of the Expenses (% of total expenses) of Italy in 2009 to that in 2010?
Provide a short and direct response. 0.98. What is the difference between the highest and the second highest Expenses (% of total expenses) in Bosnia and Herzegovina?
Offer a terse response. 0.97. What is the difference between the highest and the second highest Expenses (% of total expenses) of Italy?
Provide a succinct answer. 0.14. What is the difference between the highest and the second highest Expenses (% of total expenses) in Mali?
Provide a short and direct response. 0.98. What is the difference between the highest and the second highest Expenses (% of total expenses) in Netherlands?
Offer a terse response. 0.01. What is the difference between the highest and the lowest Expenses (% of total expenses) of Bosnia and Herzegovina?
Offer a very short reply. 2.21. What is the difference between the highest and the lowest Expenses (% of total expenses) in Italy?
Your answer should be compact. 1.4. What is the difference between the highest and the lowest Expenses (% of total expenses) of Mali?
Provide a short and direct response. 4.4. What is the difference between the highest and the lowest Expenses (% of total expenses) of Netherlands?
Your response must be concise. 1.01. 